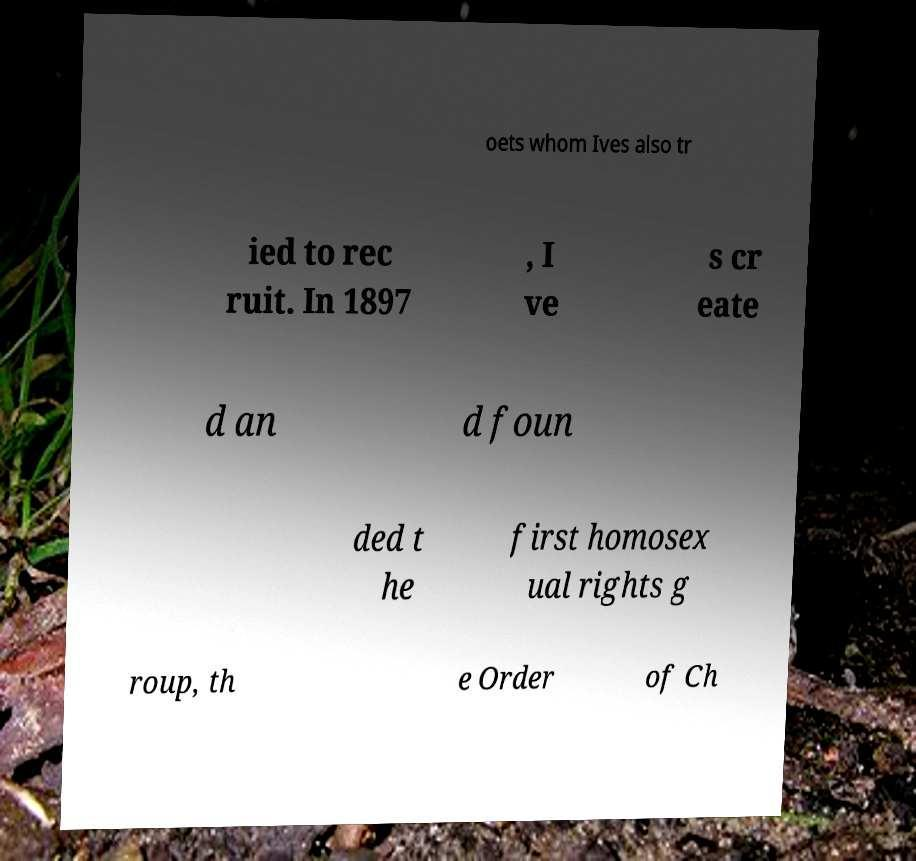Can you read and provide the text displayed in the image?This photo seems to have some interesting text. Can you extract and type it out for me? oets whom Ives also tr ied to rec ruit. In 1897 , I ve s cr eate d an d foun ded t he first homosex ual rights g roup, th e Order of Ch 